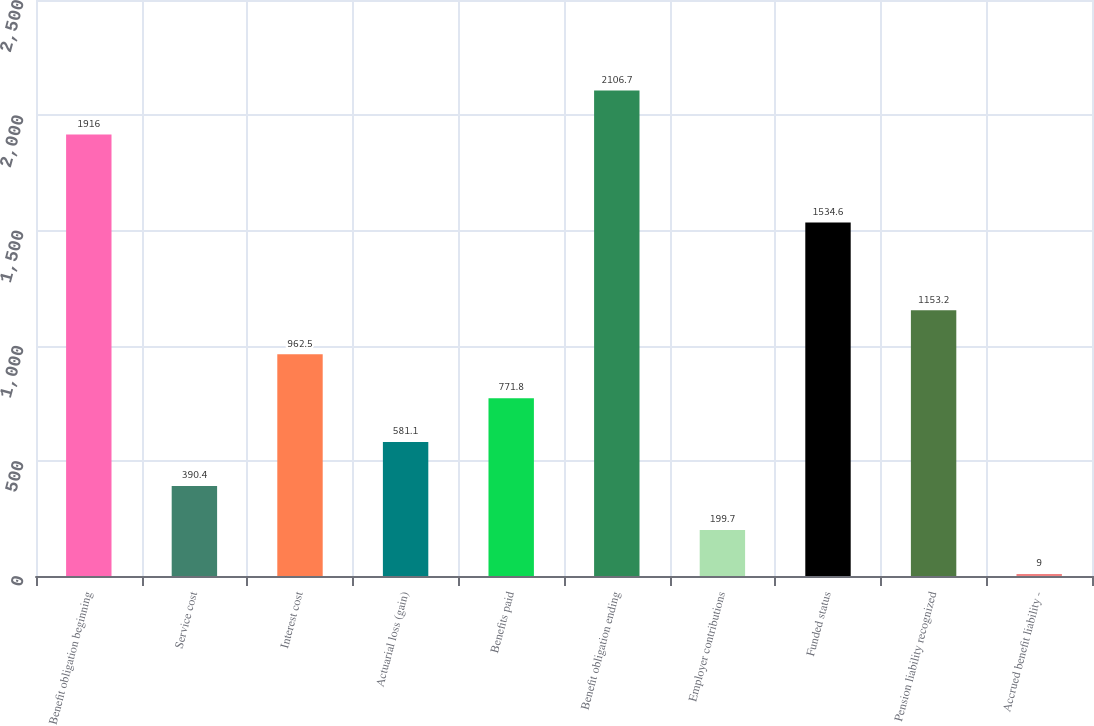Convert chart. <chart><loc_0><loc_0><loc_500><loc_500><bar_chart><fcel>Benefit obligation beginning<fcel>Service cost<fcel>Interest cost<fcel>Actuarial loss (gain)<fcel>Benefits paid<fcel>Benefit obligation ending<fcel>Employer contributions<fcel>Funded status<fcel>Pension liability recognized<fcel>Accrued benefit liability -<nl><fcel>1916<fcel>390.4<fcel>962.5<fcel>581.1<fcel>771.8<fcel>2106.7<fcel>199.7<fcel>1534.6<fcel>1153.2<fcel>9<nl></chart> 